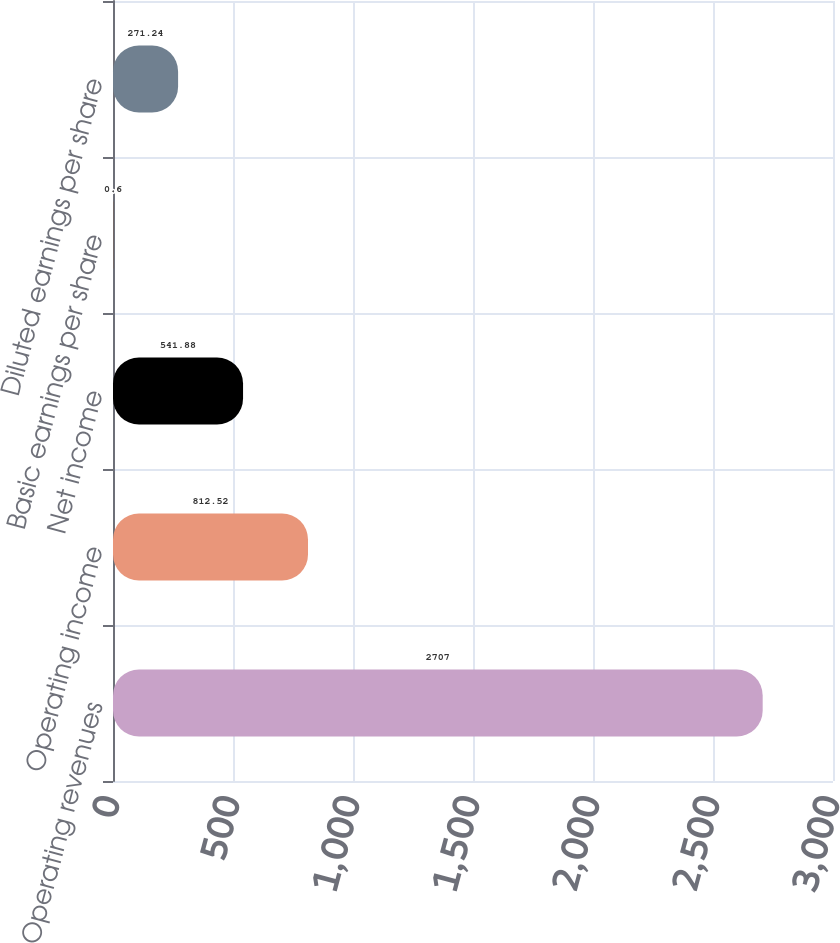Convert chart to OTSL. <chart><loc_0><loc_0><loc_500><loc_500><bar_chart><fcel>Operating revenues<fcel>Operating income<fcel>Net income<fcel>Basic earnings per share<fcel>Diluted earnings per share<nl><fcel>2707<fcel>812.52<fcel>541.88<fcel>0.6<fcel>271.24<nl></chart> 